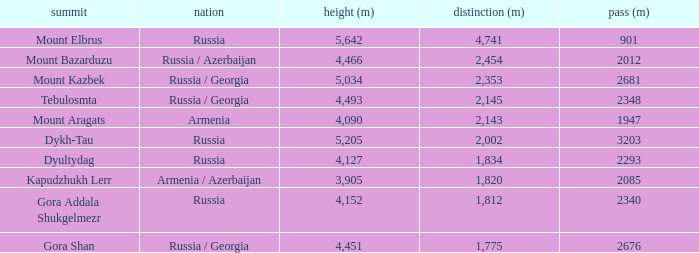With a Col (m) larger than 2012, what is Mount Kazbek's Prominence (m)? 2353.0. 